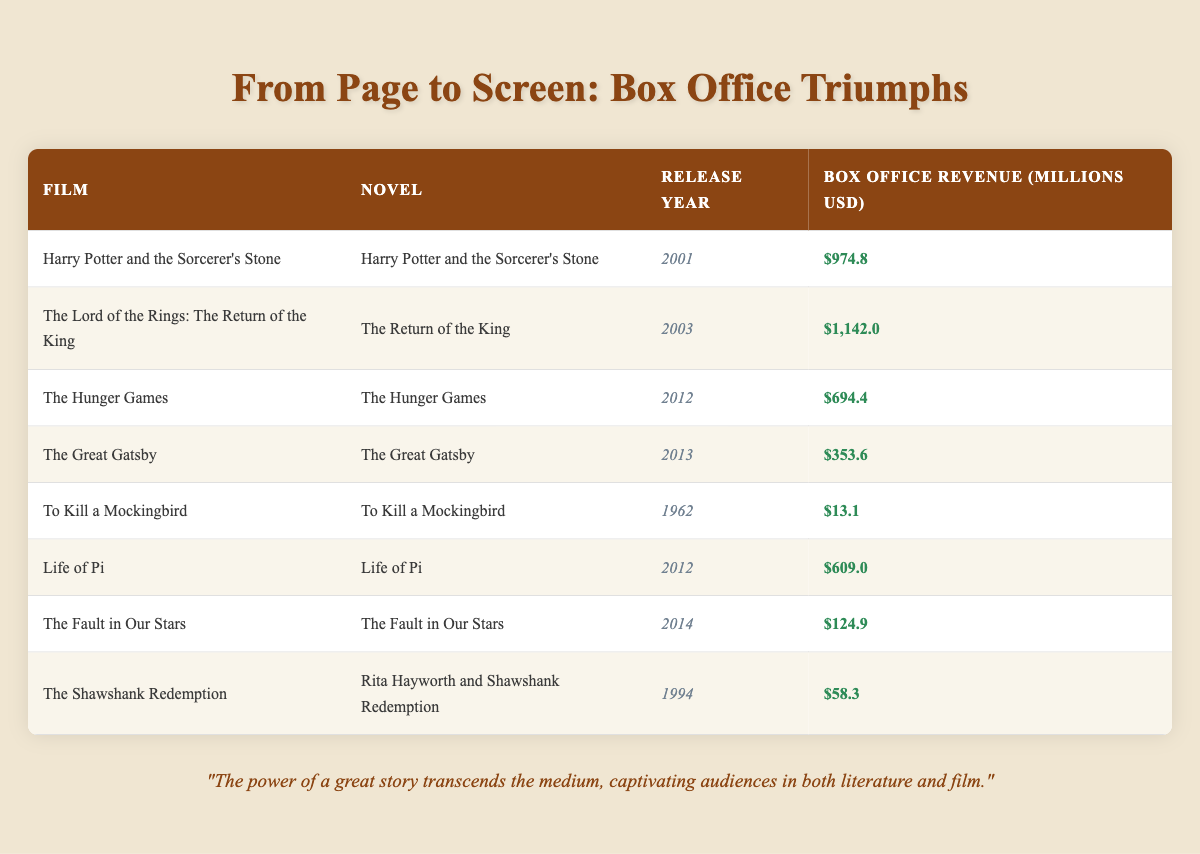What is the box office revenue of "The Hunger Games"? The table lists the box office revenue directly under the corresponding film. For "The Hunger Games," it shows a box office revenue of 694.4 million USD.
Answer: 694.4 million USD Which film, adapted from a novel, had the highest box office revenue? By examining the box office revenue figures for each film, "The Lord of the Rings: The Return of the King" has the highest revenue at 1,142.0 million USD.
Answer: "The Lord of the Rings: The Return of the King" How much more revenue did "Harry Potter and the Sorcerer's Stone" generate than "To Kill a Mockingbird"? We find the revenue for both films: "Harry Potter and the Sorcerer's Stone" is 974.8 million USD and "To Kill a Mockingbird" is 13.1 million USD. Subtracting these gives 974.8 - 13.1 = 961.7 million USD.
Answer: 961.7 million USD Is it true that "The Fault in Our Stars" was released earlier than "Life of Pi"? We check the release years for both films. "The Fault in Our Stars" was released in 2014 and "Life of Pi" in 2012. Since 2014 is after 2012, the statement is false.
Answer: No What is the total box office revenue of all films released in the 2000s? We sum the revenues of the films released between 2000 and 2009: "Harry Potter and the Sorcerer's Stone" (974.8) + "The Lord of the Rings: The Return of the King" (1,142.0) = 2,116.8 million USD. This is the total revenue for the films from that decade.
Answer: 2,116.8 million USD How many films listed had a box office revenue of less than 100 million USD? We review each film's revenue and find "The Fault in Our Stars" (124.9) and "The Shawshank Redemption" (58.3), which is the only one under 100 million USD. This means there is one film that meets this criterion.
Answer: 1 What is the average box office revenue of the films released in the 2010s? The films released in the 2010s are "The Hunger Games" (694.4), "Life of Pi" (609.0), and "The Fault in Our Stars" (124.9). Their sum is 694.4 + 609.0 + 124.9 = 1428.3 million USD. Dividing by 3 gives an average of 476.1 million USD.
Answer: 476.1 million USD Which novel adaptation had a release year closest to 2000? "Harry Potter and the Sorcerer's Stone" was released in 2001, making it the film adaptation with the release year closest to 2000 compared to the others in the list.
Answer: "Harry Potter and the Sorcerer's Stone" Did any film gross below 100 million USD? By reviewing the revenues, we see that "To Kill a Mockingbird" (13.1) and "The Shawshank Redemption" (58.3) both earned below 100 million USD, confirming the existence of such films.
Answer: Yes 